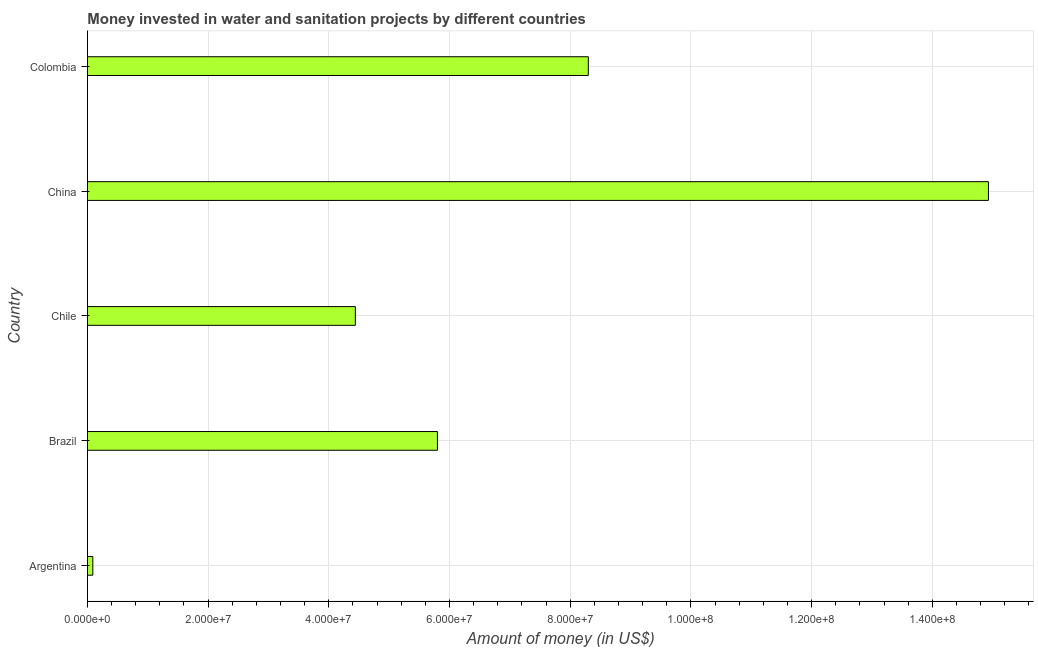Does the graph contain any zero values?
Keep it short and to the point. No. What is the title of the graph?
Make the answer very short. Money invested in water and sanitation projects by different countries. What is the label or title of the X-axis?
Make the answer very short. Amount of money (in US$). What is the investment in Chile?
Make the answer very short. 4.44e+07. Across all countries, what is the maximum investment?
Make the answer very short. 1.49e+08. Across all countries, what is the minimum investment?
Your answer should be compact. 9.00e+05. What is the sum of the investment?
Offer a terse response. 3.36e+08. What is the difference between the investment in Argentina and Chile?
Provide a succinct answer. -4.35e+07. What is the average investment per country?
Offer a terse response. 6.71e+07. What is the median investment?
Keep it short and to the point. 5.80e+07. What is the ratio of the investment in Argentina to that in Brazil?
Give a very brief answer. 0.02. Is the investment in Argentina less than that in China?
Ensure brevity in your answer.  Yes. What is the difference between the highest and the second highest investment?
Provide a succinct answer. 6.63e+07. What is the difference between the highest and the lowest investment?
Offer a terse response. 1.48e+08. In how many countries, is the investment greater than the average investment taken over all countries?
Ensure brevity in your answer.  2. How many bars are there?
Offer a very short reply. 5. Are all the bars in the graph horizontal?
Provide a short and direct response. Yes. What is the difference between two consecutive major ticks on the X-axis?
Offer a very short reply. 2.00e+07. What is the Amount of money (in US$) in Brazil?
Offer a terse response. 5.80e+07. What is the Amount of money (in US$) of Chile?
Offer a very short reply. 4.44e+07. What is the Amount of money (in US$) of China?
Your answer should be very brief. 1.49e+08. What is the Amount of money (in US$) of Colombia?
Offer a terse response. 8.30e+07. What is the difference between the Amount of money (in US$) in Argentina and Brazil?
Ensure brevity in your answer.  -5.71e+07. What is the difference between the Amount of money (in US$) in Argentina and Chile?
Your answer should be very brief. -4.35e+07. What is the difference between the Amount of money (in US$) in Argentina and China?
Offer a very short reply. -1.48e+08. What is the difference between the Amount of money (in US$) in Argentina and Colombia?
Your answer should be compact. -8.21e+07. What is the difference between the Amount of money (in US$) in Brazil and Chile?
Provide a short and direct response. 1.36e+07. What is the difference between the Amount of money (in US$) in Brazil and China?
Give a very brief answer. -9.13e+07. What is the difference between the Amount of money (in US$) in Brazil and Colombia?
Your answer should be compact. -2.50e+07. What is the difference between the Amount of money (in US$) in Chile and China?
Offer a very short reply. -1.05e+08. What is the difference between the Amount of money (in US$) in Chile and Colombia?
Your answer should be compact. -3.86e+07. What is the difference between the Amount of money (in US$) in China and Colombia?
Provide a short and direct response. 6.63e+07. What is the ratio of the Amount of money (in US$) in Argentina to that in Brazil?
Provide a short and direct response. 0.02. What is the ratio of the Amount of money (in US$) in Argentina to that in Chile?
Keep it short and to the point. 0.02. What is the ratio of the Amount of money (in US$) in Argentina to that in China?
Your answer should be very brief. 0.01. What is the ratio of the Amount of money (in US$) in Argentina to that in Colombia?
Give a very brief answer. 0.01. What is the ratio of the Amount of money (in US$) in Brazil to that in Chile?
Give a very brief answer. 1.31. What is the ratio of the Amount of money (in US$) in Brazil to that in China?
Provide a short and direct response. 0.39. What is the ratio of the Amount of money (in US$) in Brazil to that in Colombia?
Ensure brevity in your answer.  0.7. What is the ratio of the Amount of money (in US$) in Chile to that in China?
Give a very brief answer. 0.3. What is the ratio of the Amount of money (in US$) in Chile to that in Colombia?
Ensure brevity in your answer.  0.54. What is the ratio of the Amount of money (in US$) in China to that in Colombia?
Offer a very short reply. 1.8. 